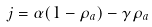<formula> <loc_0><loc_0><loc_500><loc_500>j & = \alpha ( 1 - \rho _ { a } ) - \gamma \rho _ { a }</formula> 